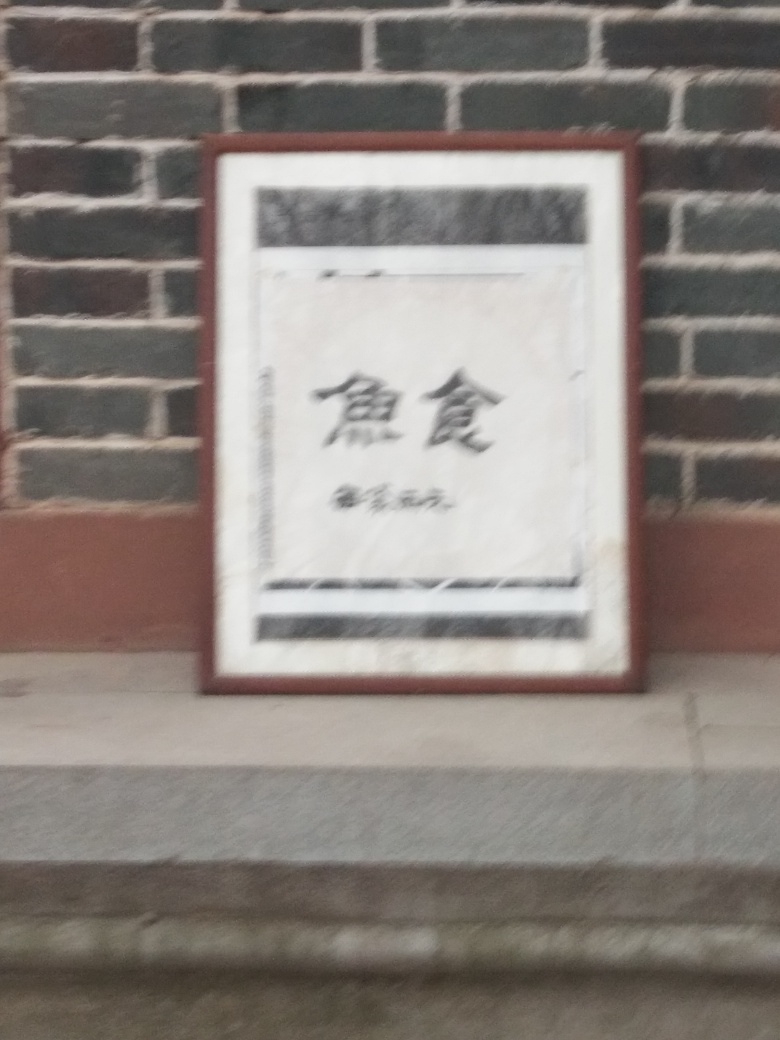Is the image visually appealing? The image's visual appeal is subjective and can vary greatly from person to person. For some, the arrangement of the framed sign on the brick wall could present a certain aesthetic; however, the blurriness of the photo detracts from its potential beauty. A clearer, sharper image could help in better determining its visual appeal. 